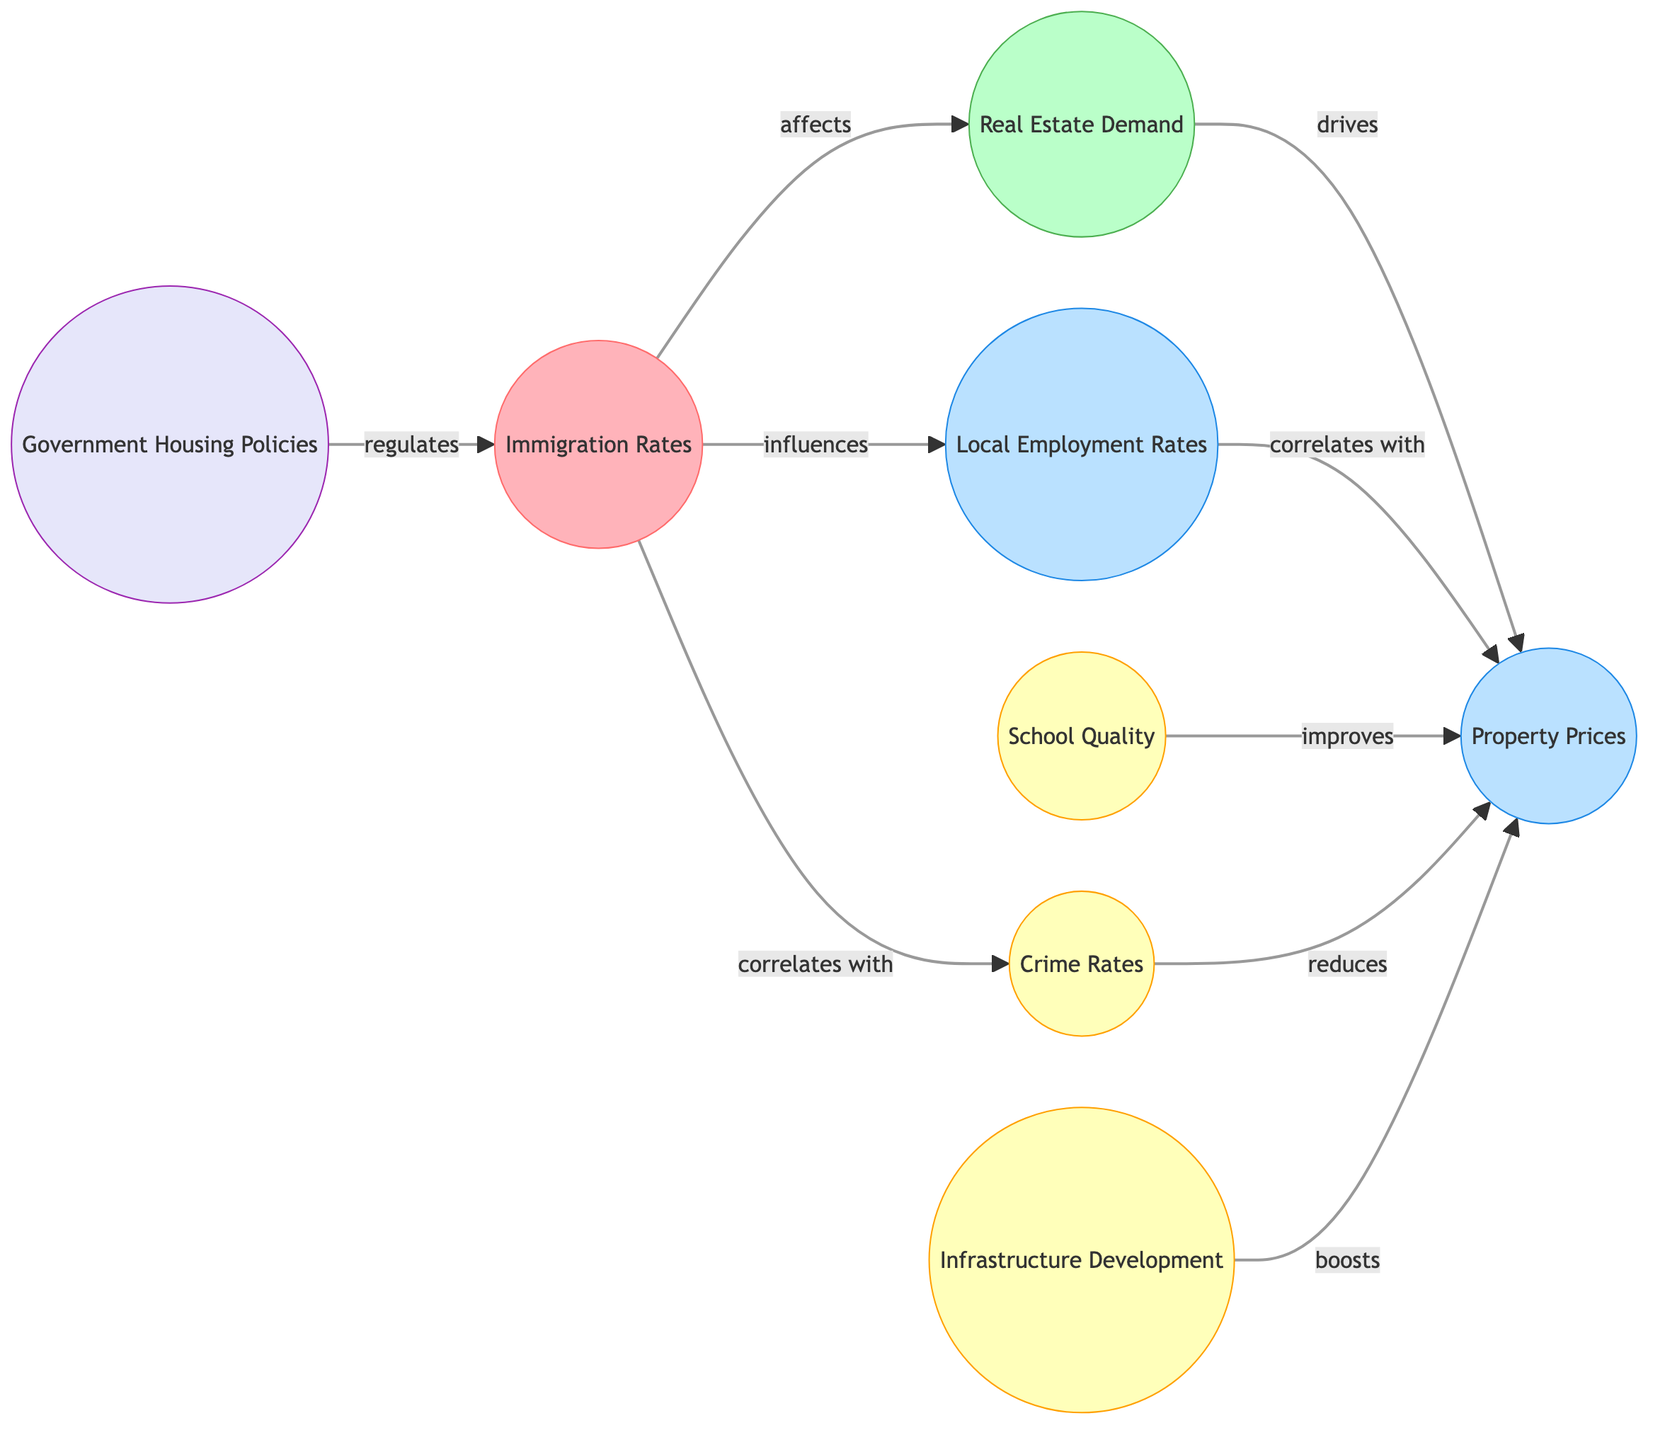What are the nodes related to Community Factors? The nodes specifically labeled under Community Factors in the diagram are School Quality, Crime Rates, and Infrastructure Development. These nodes are visually grouped and categorized as community factors, showing their relevance to the overarching theme.
Answer: School Quality, Crime Rates, Infrastructure Development How many edges are present in the diagram? To find the number of edges in the diagram, we count each connection in the list of relationships shown between nodes. There are eight distinct connections documented in the edges section.
Answer: 8 What is the relationship between Immigration Rates and Real Estate Demand? The diagram indicates a direct relationship where Immigration Rates affect Real Estate Demand. This influence is represented by an edge labeled "affects," clearly showing how one impacts the other.
Answer: affects Which node directly drives Property Prices? The only node that directly drives Property Prices in the diagram is Real Estate Demand. The edge labeled "drives" indicates that the flow of influence from Real Estate Demand to Property Prices is direct and significant.
Answer: Real Estate Demand How do Local Employment Rates correlate with Property Prices? The diagram shows that Local Employment Rates correlate with Property Prices through a relationship labeled as "correlates with." This indicates a relationship where changes in Local Employment Rates are associated with changes in Property Prices.
Answer: correlates with What community factor reduces Property Prices? The node identified as Crime Rates is noted as reducing Property Prices according to the relationship labeled "reduces" in the diagram. This captures a negative influence on Property Prices stemming from Crime Rates.
Answer: reduces What node is regulated by Government Housing Policies? Immigration Rates is the node that is regulated by Government Housing Policies as shown by the edge labeled "regulates." This indicates a governing influence that manages or controls the immigration aspect in relation to housing.
Answer: Immigration Rates What is the effect of Infrastructure Development on Property Prices? Infrastructure Development boosts Property Prices as indicated in the diagram, where the edge is labeled "boosts." This suggests a positive relationship where development contributes to higher property values.
Answer: boosts What is the correlation between Immigration Rates and Crime Rates? The document states that Immigration Rates correlate with Crime Rates, which is evident in the diagram through the relationship labeled "correlates with" between these two nodes. This reflects a statistical relationship between immigration levels and crime statistics.
Answer: correlates with 